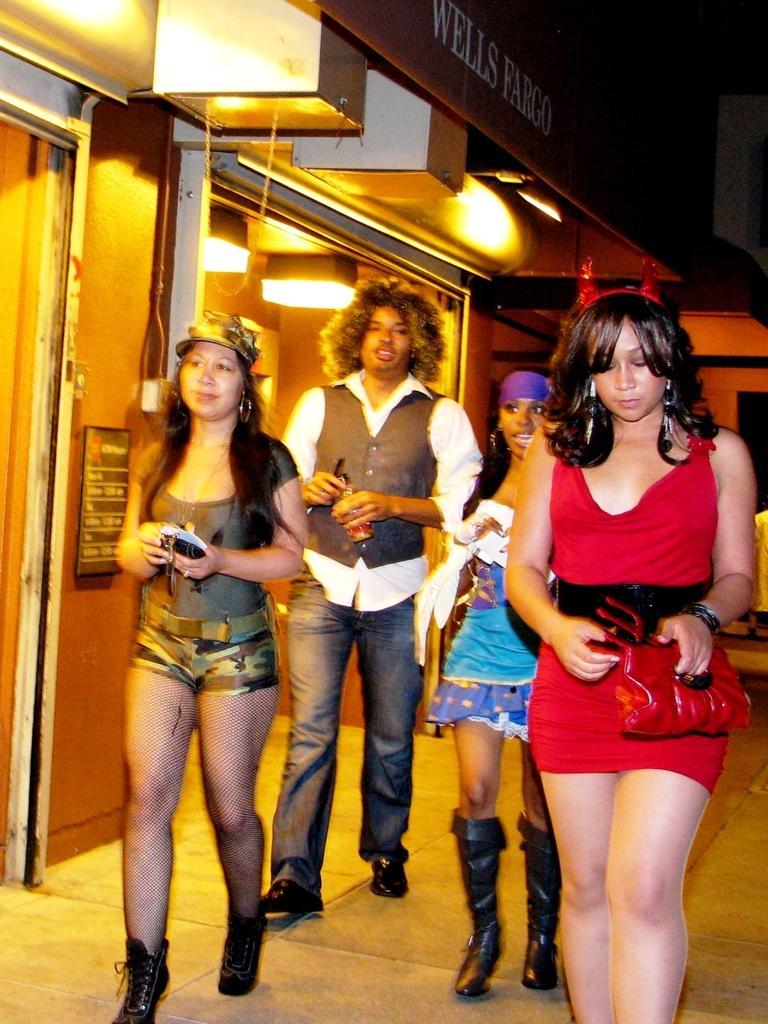Can you describe this image briefly? In the image we can see there are people standing on the footpath and there is a building. It's written ¨Wells Fargo¨ on the hoarding on the building. 